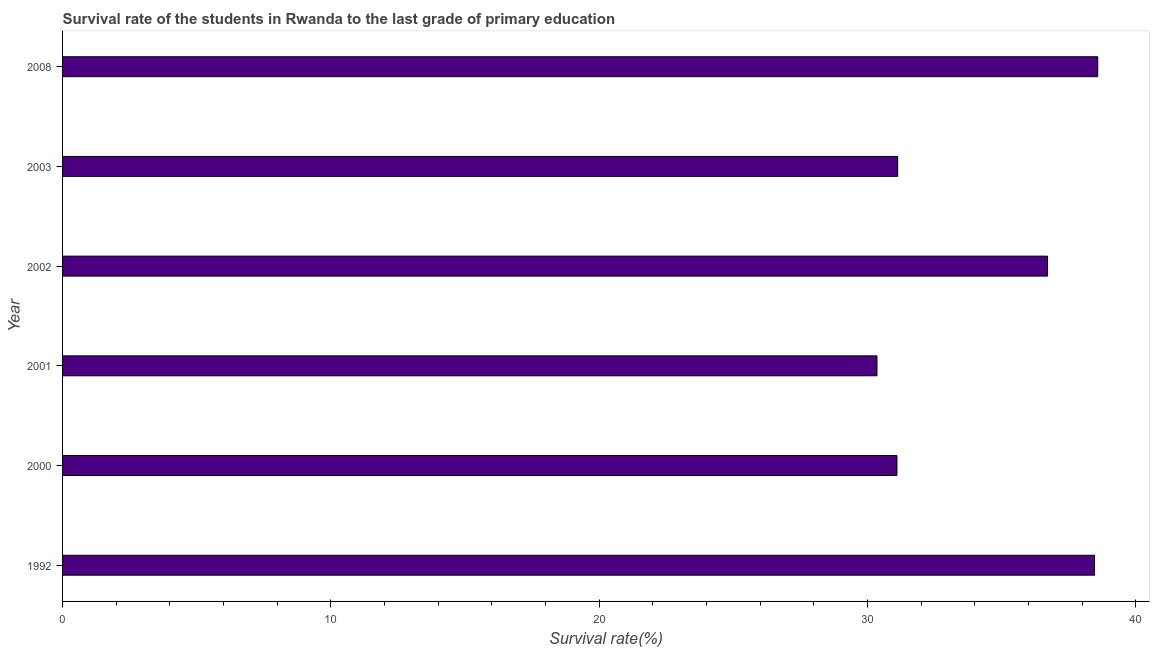Does the graph contain any zero values?
Keep it short and to the point. No. Does the graph contain grids?
Provide a short and direct response. No. What is the title of the graph?
Offer a terse response. Survival rate of the students in Rwanda to the last grade of primary education. What is the label or title of the X-axis?
Your answer should be compact. Survival rate(%). What is the label or title of the Y-axis?
Keep it short and to the point. Year. What is the survival rate in primary education in 2001?
Give a very brief answer. 30.36. Across all years, what is the maximum survival rate in primary education?
Make the answer very short. 38.59. Across all years, what is the minimum survival rate in primary education?
Ensure brevity in your answer.  30.36. In which year was the survival rate in primary education maximum?
Offer a very short reply. 2008. In which year was the survival rate in primary education minimum?
Your answer should be very brief. 2001. What is the sum of the survival rate in primary education?
Provide a short and direct response. 206.36. What is the difference between the survival rate in primary education in 2000 and 2002?
Ensure brevity in your answer.  -5.61. What is the average survival rate in primary education per year?
Provide a short and direct response. 34.39. What is the median survival rate in primary education?
Make the answer very short. 33.92. In how many years, is the survival rate in primary education greater than 8 %?
Give a very brief answer. 6. Do a majority of the years between 2003 and 2008 (inclusive) have survival rate in primary education greater than 26 %?
Your response must be concise. Yes. What is the difference between the highest and the second highest survival rate in primary education?
Offer a terse response. 0.12. Is the sum of the survival rate in primary education in 1992 and 2002 greater than the maximum survival rate in primary education across all years?
Offer a terse response. Yes. What is the difference between the highest and the lowest survival rate in primary education?
Offer a terse response. 8.23. In how many years, is the survival rate in primary education greater than the average survival rate in primary education taken over all years?
Ensure brevity in your answer.  3. How many years are there in the graph?
Provide a short and direct response. 6. What is the Survival rate(%) in 1992?
Keep it short and to the point. 38.47. What is the Survival rate(%) in 2000?
Your response must be concise. 31.1. What is the Survival rate(%) in 2001?
Your answer should be compact. 30.36. What is the Survival rate(%) in 2002?
Keep it short and to the point. 36.72. What is the Survival rate(%) of 2003?
Your answer should be very brief. 31.13. What is the Survival rate(%) of 2008?
Keep it short and to the point. 38.59. What is the difference between the Survival rate(%) in 1992 and 2000?
Offer a terse response. 7.37. What is the difference between the Survival rate(%) in 1992 and 2001?
Offer a very short reply. 8.11. What is the difference between the Survival rate(%) in 1992 and 2002?
Provide a short and direct response. 1.75. What is the difference between the Survival rate(%) in 1992 and 2003?
Keep it short and to the point. 7.34. What is the difference between the Survival rate(%) in 1992 and 2008?
Your answer should be compact. -0.12. What is the difference between the Survival rate(%) in 2000 and 2001?
Offer a very short reply. 0.74. What is the difference between the Survival rate(%) in 2000 and 2002?
Offer a very short reply. -5.61. What is the difference between the Survival rate(%) in 2000 and 2003?
Your answer should be compact. -0.03. What is the difference between the Survival rate(%) in 2000 and 2008?
Your answer should be very brief. -7.48. What is the difference between the Survival rate(%) in 2001 and 2002?
Make the answer very short. -6.36. What is the difference between the Survival rate(%) in 2001 and 2003?
Ensure brevity in your answer.  -0.77. What is the difference between the Survival rate(%) in 2001 and 2008?
Ensure brevity in your answer.  -8.23. What is the difference between the Survival rate(%) in 2002 and 2003?
Your answer should be very brief. 5.59. What is the difference between the Survival rate(%) in 2002 and 2008?
Ensure brevity in your answer.  -1.87. What is the difference between the Survival rate(%) in 2003 and 2008?
Provide a succinct answer. -7.46. What is the ratio of the Survival rate(%) in 1992 to that in 2000?
Your response must be concise. 1.24. What is the ratio of the Survival rate(%) in 1992 to that in 2001?
Offer a terse response. 1.27. What is the ratio of the Survival rate(%) in 1992 to that in 2002?
Your answer should be very brief. 1.05. What is the ratio of the Survival rate(%) in 1992 to that in 2003?
Provide a succinct answer. 1.24. What is the ratio of the Survival rate(%) in 2000 to that in 2002?
Offer a very short reply. 0.85. What is the ratio of the Survival rate(%) in 2000 to that in 2008?
Offer a terse response. 0.81. What is the ratio of the Survival rate(%) in 2001 to that in 2002?
Provide a succinct answer. 0.83. What is the ratio of the Survival rate(%) in 2001 to that in 2008?
Offer a very short reply. 0.79. What is the ratio of the Survival rate(%) in 2002 to that in 2003?
Keep it short and to the point. 1.18. What is the ratio of the Survival rate(%) in 2003 to that in 2008?
Offer a very short reply. 0.81. 